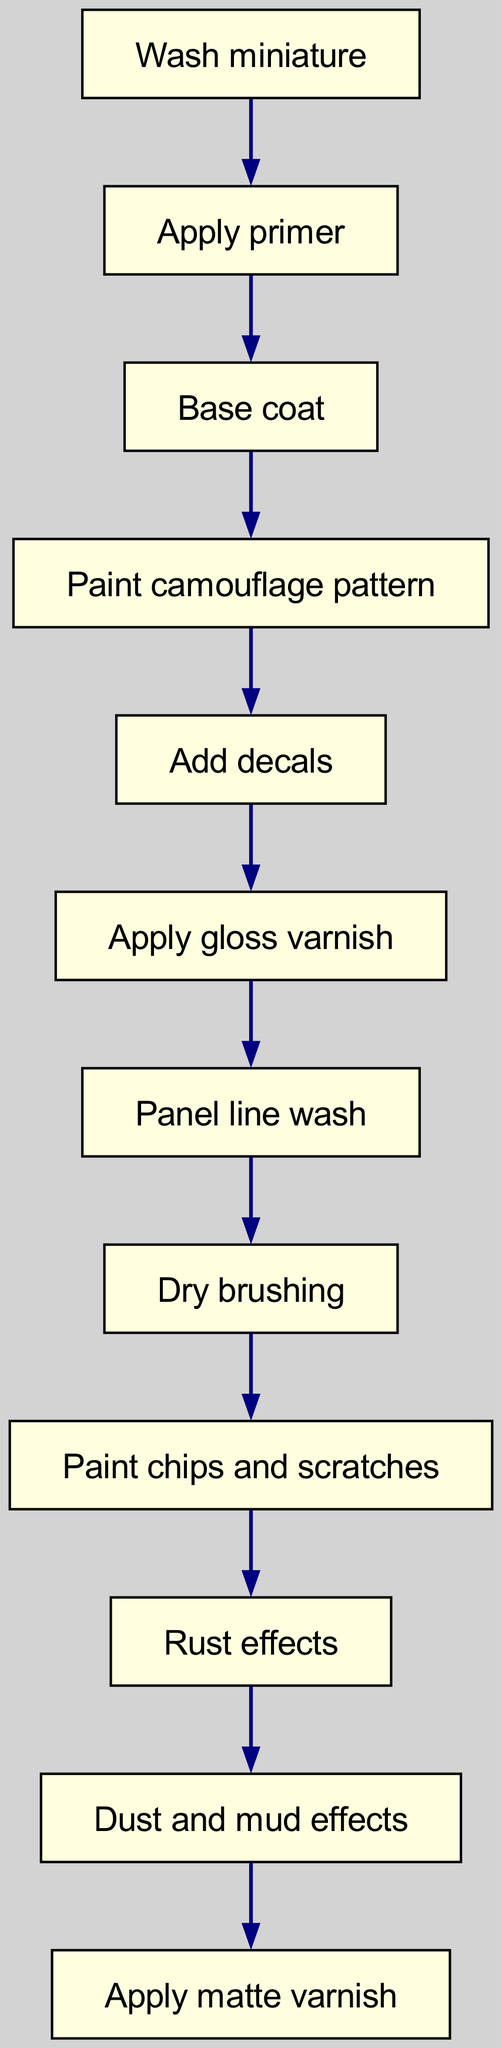What is the first step in the painting process? The diagram specifies that the first step is to "Wash miniature," which is the initial action taken before any other steps.
Answer: Wash miniature How many total nodes are present in the diagram? To determine the total number of nodes, we can count each unique step listed in the diagram. There are 11 nodes in total, as provided in the data.
Answer: 11 What step comes after "Apply gloss varnish"? The diagram shows a sequential flow where the step that follows "Apply gloss varnish" is "Panel line wash." Therefore, the next action is indicated clearly.
Answer: Panel line wash What is the last step in the painting process? The last visible step in the sequence of the diagram is "Apply matte varnish," which concludes the painting process after all other steps have been completed.
Answer: Apply matte varnish Which step precedes "Add decals"? By moving backward in the diagram from "Add decals," we see that the step immediately before it is "Paint camouflage pattern." This relationship indicates the order of operations.
Answer: Paint camouflage pattern If "Dry brushing" is done, which step must have been completed beforehand? Referring to the flow of the diagram, "Dry brushing" comes after "Panel line wash," meaning that this step must have been completed prior to performing dry brushing.
Answer: Panel line wash What step directly leads to the "Dust and mud effects"? The flowchart indicates that "Rust effects" is the step that leads directly to "Dust and mud effects," creating a clear relationship between these two actions.
Answer: Rust effects How many edges are in the diagram? To find the total number of edges, we can count each connection made between the nodes. According to the provided information, there are 10 edges in the diagram.
Answer: 10 What action is performed after applying the base coat? The flowchart indicates that the action following "Base coat" is "Paint camouflage pattern," establishing a direct sequence in the painting process.
Answer: Paint camouflage pattern 